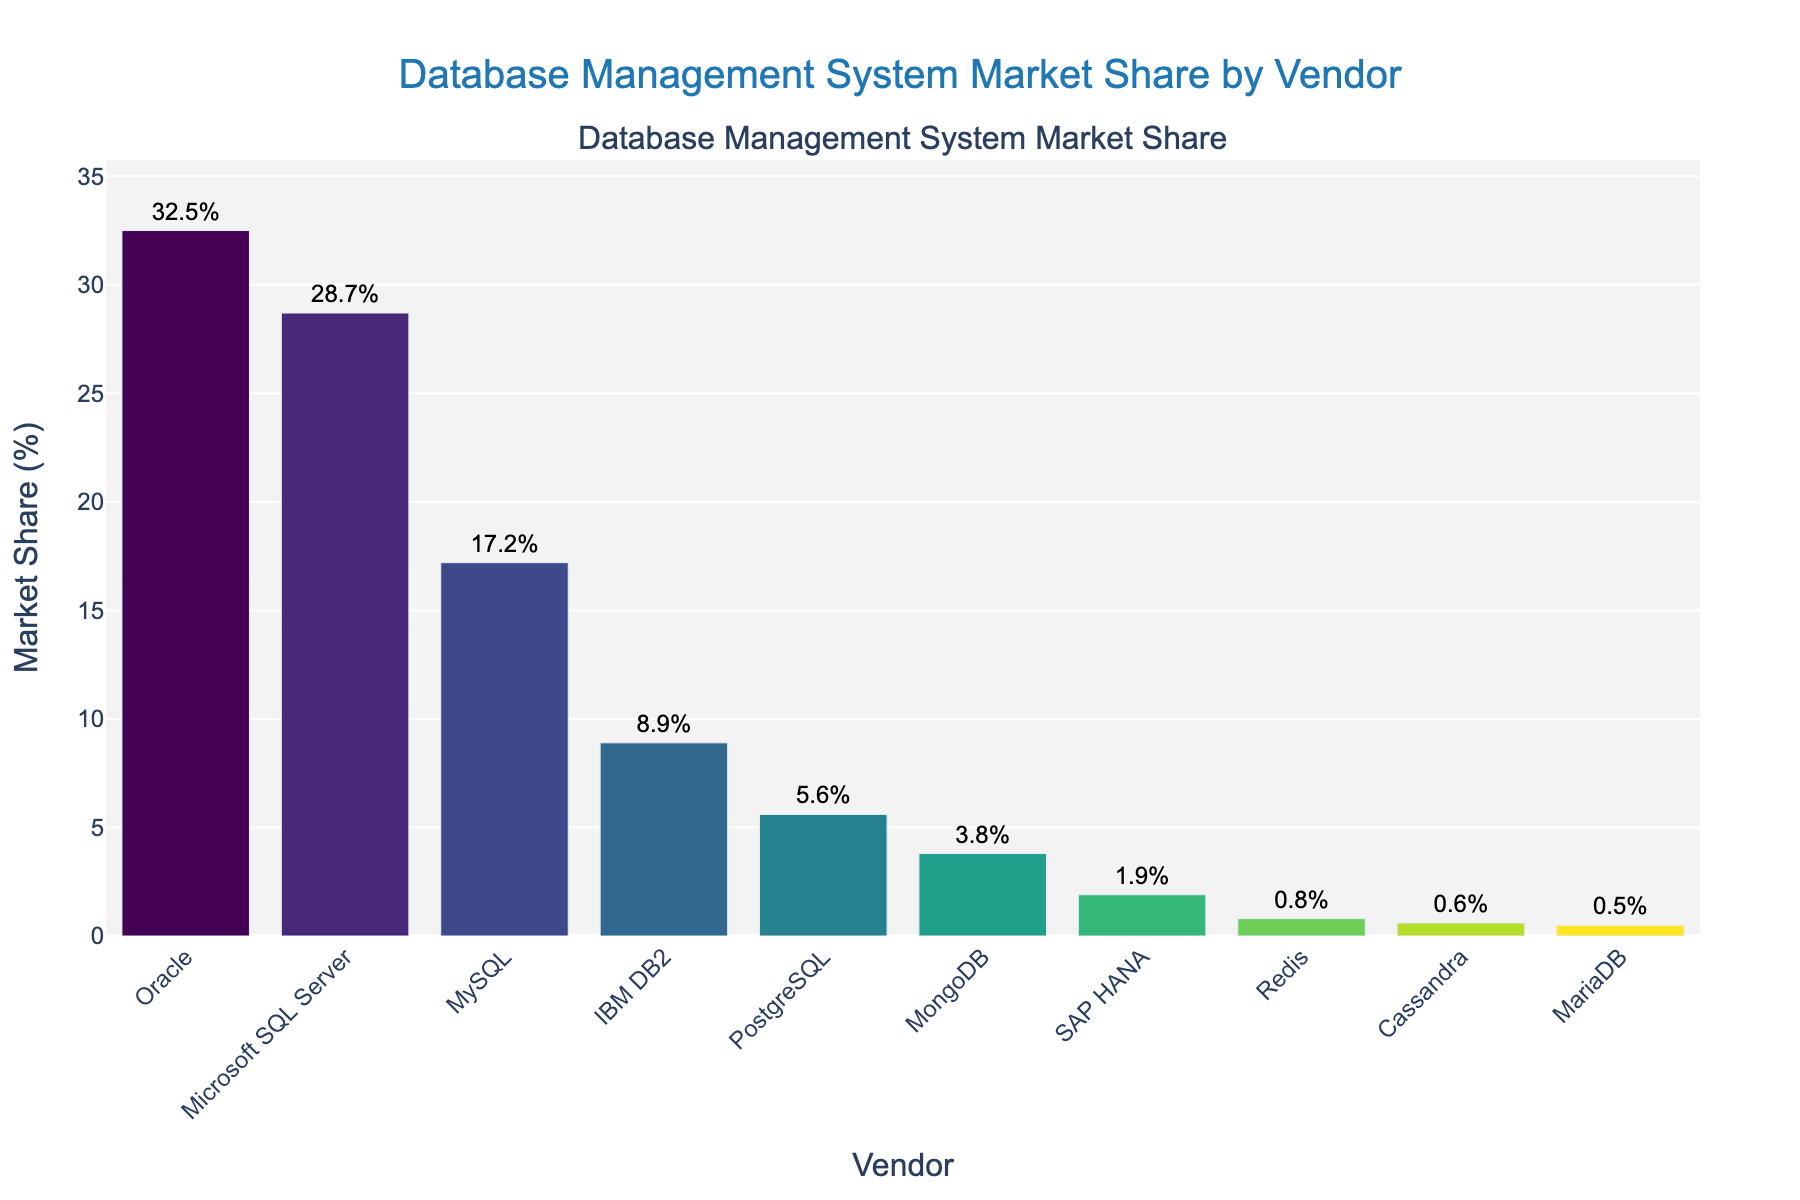which vendor has the highest market share? Oracle has the highest bar in the plot, indicating it has the largest market share.
Answer: Oracle what is the combined market share of the top two vendors? The top two vendors are Oracle with 32.5% and Microsoft SQL Server with 28.7%. Adding these together gives 32.5 + 28.7 = 61.2%.
Answer: 61.2% which vendor has the lowest market share? MariaDB has the shortest bar in the plot with a market share of 0.5%.
Answer: MariaDB how does PostgreSQL's market share compare to MongoDB's market share? PostgreSQL has a market share of 5.6% while MongoDB has a market share of 3.8%. Subtracting MongoDB's share from PostgreSQL's share gives 5.6 - 3.8 = 1.8%. Thus, PostgreSQL's market share is 1.8% higher than MongoDB's.
Answer: 1.8% higher what is the average market share of the vendors with less than 2% market share? Vendors with less than 2% market share are SAP HANA (1.9%), Redis (0.8%), Cassandra (0.6%), and MariaDB (0.5%). The sum of their market shares is 1.9 + 0.8 + 0.6 + 0.5 = 3.8%. As there are 4 vendors, the average is 3.8 / 4 = 0.95%.
Answer: 0.95% how does the market share of MySQL compare to IBM DB2? MySQL has a market share of 17.2% while IBM DB2 has a market share of 8.9%. Subtracting IBM DB2's share from MySQL's share gives 17.2 - 8.9 = 8.3%. Thus, MySQL's market share is 8.3% higher than IBM DB2's.
Answer: 8.3% higher what is the market share range covered in the chart? The highest market share is 32.5% (Oracle) and the lowest is 0.5% (MariaDB). Therefore, the range is 32.5 - 0.5 = 32%.
Answer: 32% which database management system has the most contrasting color in the visual representation? The color representing Oracle, near the top of the 'Viridis' color scale, appears most visually prominent in the plot due to its high market share and color contrast.
Answer: Oracle what is the summed market share of vendors with a market share greater than 5%? Vendors with market share greater than 5% are Oracle (32.5%), Microsoft SQL Server (28.7%), MySQL (17.2%) and PostgreSQL (5.6%). Summing these shares gives 32.5 + 28.7 + 17.2 + 5.6 = 84%.
Answer: 84% which vendor's market share is closest to 10%? IBM DB2 has a market share of 8.9%, which is closest to 10% compared to the other percentages in the chart.
Answer: IBM DB2 